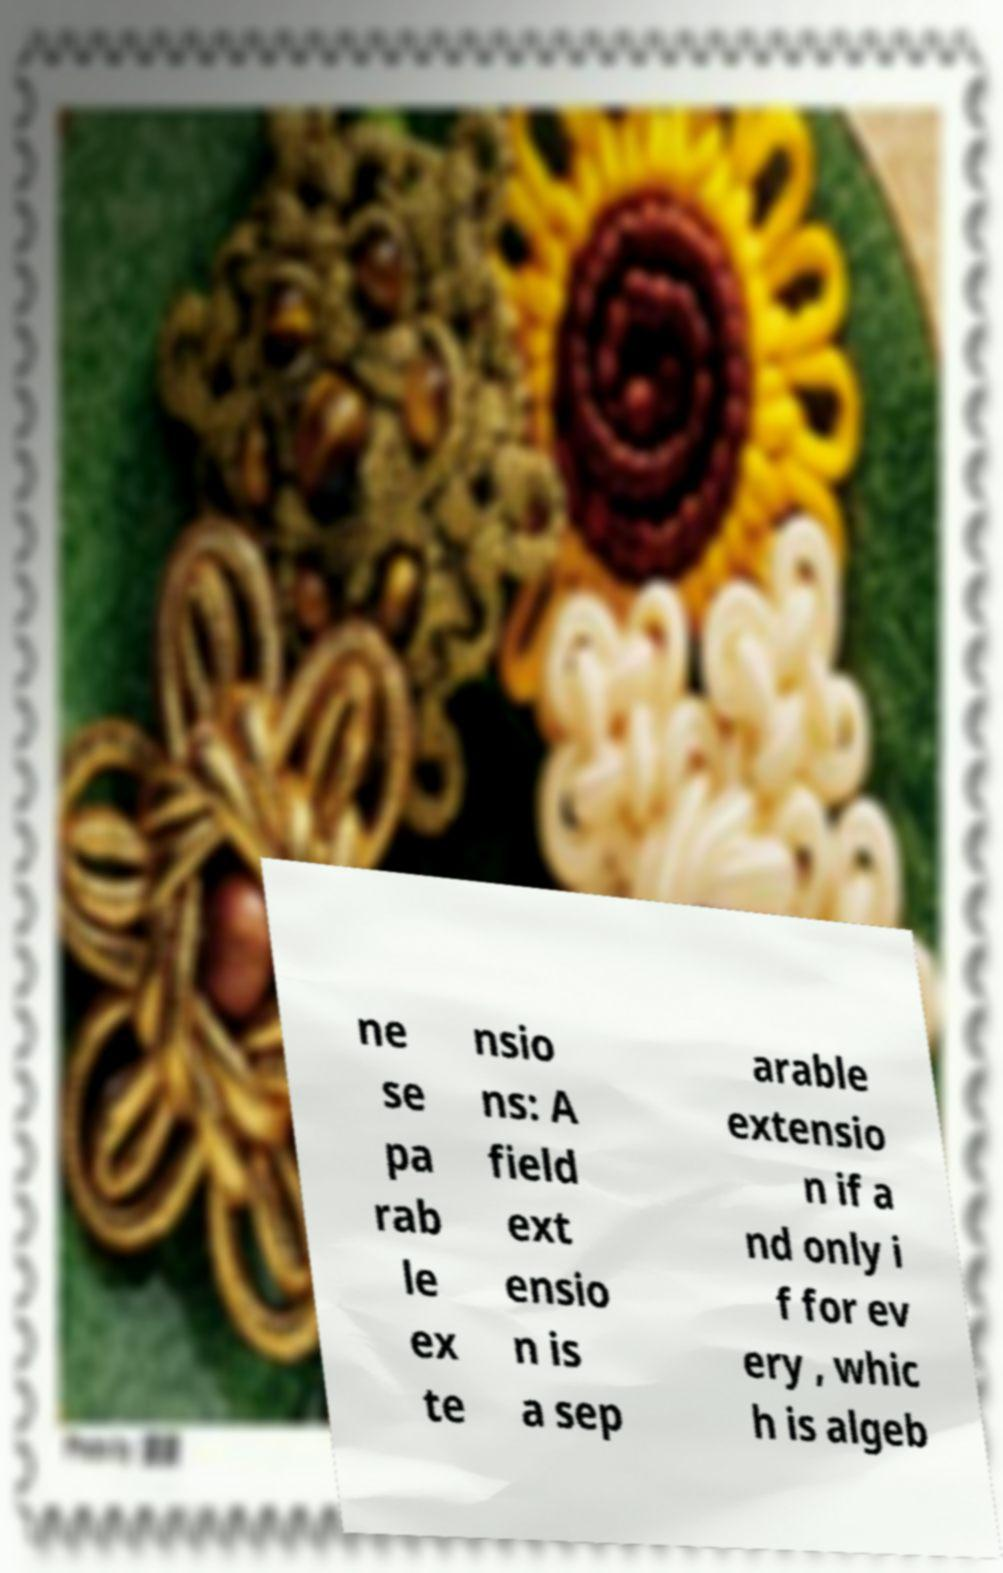Please read and relay the text visible in this image. What does it say? ne se pa rab le ex te nsio ns: A field ext ensio n is a sep arable extensio n if a nd only i f for ev ery , whic h is algeb 